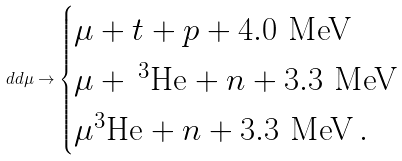Convert formula to latex. <formula><loc_0><loc_0><loc_500><loc_500>d d \mu \to \begin{cases} \mu + t + p + 4 . 0 \text { MeV} \\ \mu + \, ^ { 3 } \text {He} + n + 3 . 3 \text { MeV} \\ \mu ^ { 3 } \text {He} + n + 3 . 3 \text { MeV} \, . \end{cases}</formula> 